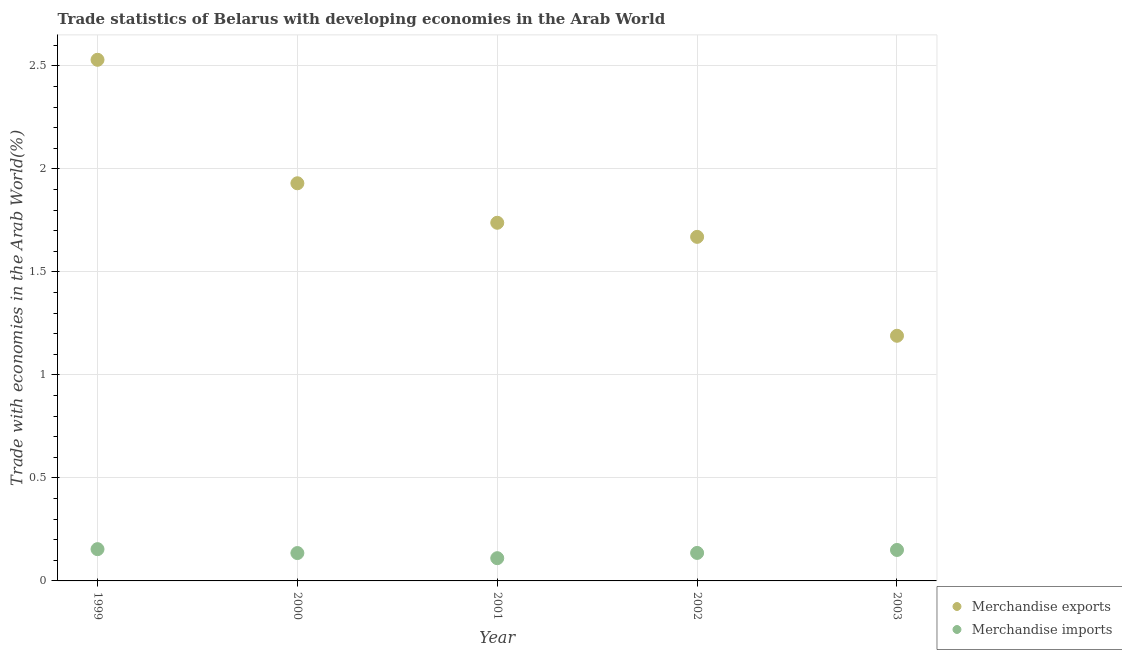Is the number of dotlines equal to the number of legend labels?
Ensure brevity in your answer.  Yes. What is the merchandise imports in 2002?
Your response must be concise. 0.14. Across all years, what is the maximum merchandise imports?
Keep it short and to the point. 0.15. Across all years, what is the minimum merchandise imports?
Keep it short and to the point. 0.11. In which year was the merchandise exports maximum?
Make the answer very short. 1999. What is the total merchandise exports in the graph?
Your answer should be very brief. 9.06. What is the difference between the merchandise exports in 2002 and that in 2003?
Keep it short and to the point. 0.48. What is the difference between the merchandise exports in 2003 and the merchandise imports in 1999?
Provide a short and direct response. 1.04. What is the average merchandise imports per year?
Offer a terse response. 0.14. In the year 2002, what is the difference between the merchandise imports and merchandise exports?
Offer a very short reply. -1.53. In how many years, is the merchandise exports greater than 0.7 %?
Offer a terse response. 5. What is the ratio of the merchandise exports in 2001 to that in 2002?
Provide a short and direct response. 1.04. Is the merchandise imports in 2001 less than that in 2003?
Your answer should be compact. Yes. Is the difference between the merchandise exports in 1999 and 2002 greater than the difference between the merchandise imports in 1999 and 2002?
Provide a succinct answer. Yes. What is the difference between the highest and the second highest merchandise imports?
Give a very brief answer. 0. What is the difference between the highest and the lowest merchandise exports?
Make the answer very short. 1.34. In how many years, is the merchandise imports greater than the average merchandise imports taken over all years?
Offer a terse response. 2. Is the sum of the merchandise exports in 2000 and 2002 greater than the maximum merchandise imports across all years?
Provide a succinct answer. Yes. Does the merchandise imports monotonically increase over the years?
Make the answer very short. No. Is the merchandise imports strictly greater than the merchandise exports over the years?
Keep it short and to the point. No. What is the difference between two consecutive major ticks on the Y-axis?
Your answer should be very brief. 0.5. Does the graph contain any zero values?
Ensure brevity in your answer.  No. Where does the legend appear in the graph?
Provide a short and direct response. Bottom right. How many legend labels are there?
Make the answer very short. 2. What is the title of the graph?
Provide a short and direct response. Trade statistics of Belarus with developing economies in the Arab World. What is the label or title of the Y-axis?
Your answer should be very brief. Trade with economies in the Arab World(%). What is the Trade with economies in the Arab World(%) of Merchandise exports in 1999?
Your response must be concise. 2.53. What is the Trade with economies in the Arab World(%) in Merchandise imports in 1999?
Offer a terse response. 0.15. What is the Trade with economies in the Arab World(%) in Merchandise exports in 2000?
Your answer should be very brief. 1.93. What is the Trade with economies in the Arab World(%) in Merchandise imports in 2000?
Provide a short and direct response. 0.14. What is the Trade with economies in the Arab World(%) of Merchandise exports in 2001?
Provide a succinct answer. 1.74. What is the Trade with economies in the Arab World(%) of Merchandise imports in 2001?
Your response must be concise. 0.11. What is the Trade with economies in the Arab World(%) in Merchandise exports in 2002?
Your answer should be compact. 1.67. What is the Trade with economies in the Arab World(%) in Merchandise imports in 2002?
Provide a short and direct response. 0.14. What is the Trade with economies in the Arab World(%) in Merchandise exports in 2003?
Give a very brief answer. 1.19. What is the Trade with economies in the Arab World(%) in Merchandise imports in 2003?
Offer a terse response. 0.15. Across all years, what is the maximum Trade with economies in the Arab World(%) of Merchandise exports?
Your response must be concise. 2.53. Across all years, what is the maximum Trade with economies in the Arab World(%) in Merchandise imports?
Give a very brief answer. 0.15. Across all years, what is the minimum Trade with economies in the Arab World(%) of Merchandise exports?
Keep it short and to the point. 1.19. Across all years, what is the minimum Trade with economies in the Arab World(%) in Merchandise imports?
Give a very brief answer. 0.11. What is the total Trade with economies in the Arab World(%) of Merchandise exports in the graph?
Provide a succinct answer. 9.06. What is the total Trade with economies in the Arab World(%) in Merchandise imports in the graph?
Offer a terse response. 0.69. What is the difference between the Trade with economies in the Arab World(%) in Merchandise exports in 1999 and that in 2000?
Provide a succinct answer. 0.6. What is the difference between the Trade with economies in the Arab World(%) of Merchandise imports in 1999 and that in 2000?
Give a very brief answer. 0.02. What is the difference between the Trade with economies in the Arab World(%) in Merchandise exports in 1999 and that in 2001?
Your answer should be compact. 0.79. What is the difference between the Trade with economies in the Arab World(%) in Merchandise imports in 1999 and that in 2001?
Make the answer very short. 0.04. What is the difference between the Trade with economies in the Arab World(%) in Merchandise exports in 1999 and that in 2002?
Your response must be concise. 0.86. What is the difference between the Trade with economies in the Arab World(%) of Merchandise imports in 1999 and that in 2002?
Your answer should be compact. 0.02. What is the difference between the Trade with economies in the Arab World(%) in Merchandise exports in 1999 and that in 2003?
Offer a very short reply. 1.34. What is the difference between the Trade with economies in the Arab World(%) in Merchandise imports in 1999 and that in 2003?
Your response must be concise. 0. What is the difference between the Trade with economies in the Arab World(%) of Merchandise exports in 2000 and that in 2001?
Make the answer very short. 0.19. What is the difference between the Trade with economies in the Arab World(%) of Merchandise imports in 2000 and that in 2001?
Provide a succinct answer. 0.02. What is the difference between the Trade with economies in the Arab World(%) in Merchandise exports in 2000 and that in 2002?
Provide a short and direct response. 0.26. What is the difference between the Trade with economies in the Arab World(%) of Merchandise imports in 2000 and that in 2002?
Provide a succinct answer. -0. What is the difference between the Trade with economies in the Arab World(%) in Merchandise exports in 2000 and that in 2003?
Give a very brief answer. 0.74. What is the difference between the Trade with economies in the Arab World(%) in Merchandise imports in 2000 and that in 2003?
Keep it short and to the point. -0.01. What is the difference between the Trade with economies in the Arab World(%) in Merchandise exports in 2001 and that in 2002?
Offer a very short reply. 0.07. What is the difference between the Trade with economies in the Arab World(%) of Merchandise imports in 2001 and that in 2002?
Your answer should be compact. -0.03. What is the difference between the Trade with economies in the Arab World(%) in Merchandise exports in 2001 and that in 2003?
Your answer should be very brief. 0.55. What is the difference between the Trade with economies in the Arab World(%) in Merchandise imports in 2001 and that in 2003?
Provide a succinct answer. -0.04. What is the difference between the Trade with economies in the Arab World(%) in Merchandise exports in 2002 and that in 2003?
Provide a succinct answer. 0.48. What is the difference between the Trade with economies in the Arab World(%) in Merchandise imports in 2002 and that in 2003?
Provide a succinct answer. -0.01. What is the difference between the Trade with economies in the Arab World(%) in Merchandise exports in 1999 and the Trade with economies in the Arab World(%) in Merchandise imports in 2000?
Your answer should be compact. 2.39. What is the difference between the Trade with economies in the Arab World(%) of Merchandise exports in 1999 and the Trade with economies in the Arab World(%) of Merchandise imports in 2001?
Provide a succinct answer. 2.42. What is the difference between the Trade with economies in the Arab World(%) of Merchandise exports in 1999 and the Trade with economies in the Arab World(%) of Merchandise imports in 2002?
Offer a terse response. 2.39. What is the difference between the Trade with economies in the Arab World(%) in Merchandise exports in 1999 and the Trade with economies in the Arab World(%) in Merchandise imports in 2003?
Offer a very short reply. 2.38. What is the difference between the Trade with economies in the Arab World(%) in Merchandise exports in 2000 and the Trade with economies in the Arab World(%) in Merchandise imports in 2001?
Your response must be concise. 1.82. What is the difference between the Trade with economies in the Arab World(%) in Merchandise exports in 2000 and the Trade with economies in the Arab World(%) in Merchandise imports in 2002?
Provide a succinct answer. 1.79. What is the difference between the Trade with economies in the Arab World(%) of Merchandise exports in 2000 and the Trade with economies in the Arab World(%) of Merchandise imports in 2003?
Offer a very short reply. 1.78. What is the difference between the Trade with economies in the Arab World(%) of Merchandise exports in 2001 and the Trade with economies in the Arab World(%) of Merchandise imports in 2002?
Your answer should be compact. 1.6. What is the difference between the Trade with economies in the Arab World(%) of Merchandise exports in 2001 and the Trade with economies in the Arab World(%) of Merchandise imports in 2003?
Provide a succinct answer. 1.59. What is the difference between the Trade with economies in the Arab World(%) in Merchandise exports in 2002 and the Trade with economies in the Arab World(%) in Merchandise imports in 2003?
Offer a very short reply. 1.52. What is the average Trade with economies in the Arab World(%) in Merchandise exports per year?
Offer a very short reply. 1.81. What is the average Trade with economies in the Arab World(%) of Merchandise imports per year?
Make the answer very short. 0.14. In the year 1999, what is the difference between the Trade with economies in the Arab World(%) of Merchandise exports and Trade with economies in the Arab World(%) of Merchandise imports?
Keep it short and to the point. 2.38. In the year 2000, what is the difference between the Trade with economies in the Arab World(%) in Merchandise exports and Trade with economies in the Arab World(%) in Merchandise imports?
Ensure brevity in your answer.  1.8. In the year 2001, what is the difference between the Trade with economies in the Arab World(%) of Merchandise exports and Trade with economies in the Arab World(%) of Merchandise imports?
Offer a terse response. 1.63. In the year 2002, what is the difference between the Trade with economies in the Arab World(%) of Merchandise exports and Trade with economies in the Arab World(%) of Merchandise imports?
Make the answer very short. 1.53. In the year 2003, what is the difference between the Trade with economies in the Arab World(%) in Merchandise exports and Trade with economies in the Arab World(%) in Merchandise imports?
Your answer should be compact. 1.04. What is the ratio of the Trade with economies in the Arab World(%) of Merchandise exports in 1999 to that in 2000?
Offer a very short reply. 1.31. What is the ratio of the Trade with economies in the Arab World(%) in Merchandise imports in 1999 to that in 2000?
Provide a succinct answer. 1.14. What is the ratio of the Trade with economies in the Arab World(%) of Merchandise exports in 1999 to that in 2001?
Your answer should be compact. 1.46. What is the ratio of the Trade with economies in the Arab World(%) of Merchandise imports in 1999 to that in 2001?
Offer a terse response. 1.4. What is the ratio of the Trade with economies in the Arab World(%) of Merchandise exports in 1999 to that in 2002?
Your answer should be very brief. 1.51. What is the ratio of the Trade with economies in the Arab World(%) in Merchandise imports in 1999 to that in 2002?
Make the answer very short. 1.14. What is the ratio of the Trade with economies in the Arab World(%) in Merchandise exports in 1999 to that in 2003?
Provide a succinct answer. 2.13. What is the ratio of the Trade with economies in the Arab World(%) in Merchandise exports in 2000 to that in 2001?
Your answer should be very brief. 1.11. What is the ratio of the Trade with economies in the Arab World(%) of Merchandise imports in 2000 to that in 2001?
Ensure brevity in your answer.  1.23. What is the ratio of the Trade with economies in the Arab World(%) of Merchandise exports in 2000 to that in 2002?
Offer a terse response. 1.16. What is the ratio of the Trade with economies in the Arab World(%) of Merchandise exports in 2000 to that in 2003?
Offer a terse response. 1.62. What is the ratio of the Trade with economies in the Arab World(%) of Merchandise exports in 2001 to that in 2002?
Provide a short and direct response. 1.04. What is the ratio of the Trade with economies in the Arab World(%) in Merchandise imports in 2001 to that in 2002?
Your answer should be compact. 0.81. What is the ratio of the Trade with economies in the Arab World(%) in Merchandise exports in 2001 to that in 2003?
Offer a terse response. 1.46. What is the ratio of the Trade with economies in the Arab World(%) in Merchandise imports in 2001 to that in 2003?
Your response must be concise. 0.73. What is the ratio of the Trade with economies in the Arab World(%) in Merchandise exports in 2002 to that in 2003?
Offer a terse response. 1.4. What is the ratio of the Trade with economies in the Arab World(%) of Merchandise imports in 2002 to that in 2003?
Provide a succinct answer. 0.9. What is the difference between the highest and the second highest Trade with economies in the Arab World(%) in Merchandise exports?
Your answer should be very brief. 0.6. What is the difference between the highest and the second highest Trade with economies in the Arab World(%) of Merchandise imports?
Provide a succinct answer. 0. What is the difference between the highest and the lowest Trade with economies in the Arab World(%) in Merchandise exports?
Your answer should be very brief. 1.34. What is the difference between the highest and the lowest Trade with economies in the Arab World(%) in Merchandise imports?
Your response must be concise. 0.04. 